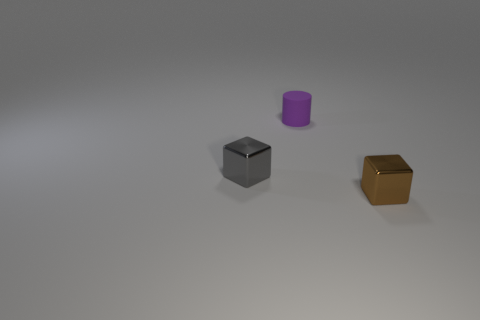What number of spheres are small yellow shiny objects or shiny things?
Your answer should be compact. 0. There is a cube that is the same size as the gray object; what is its color?
Give a very brief answer. Brown. Is there a brown metal object behind the small cube on the left side of the tiny shiny object that is in front of the tiny gray metallic object?
Make the answer very short. No. The purple object has what size?
Your answer should be very brief. Small. What number of things are either metal blocks or small gray cylinders?
Your response must be concise. 2. There is another thing that is the same material as the small brown thing; what is its color?
Ensure brevity in your answer.  Gray. There is a tiny purple matte object that is behind the gray metal cube; is it the same shape as the tiny gray shiny object?
Keep it short and to the point. No. How many things are objects left of the tiny brown shiny object or things on the right side of the cylinder?
Offer a very short reply. 3. What is the color of the other small shiny object that is the same shape as the tiny brown shiny object?
Your answer should be compact. Gray. Is there anything else that has the same shape as the tiny brown object?
Keep it short and to the point. Yes. 